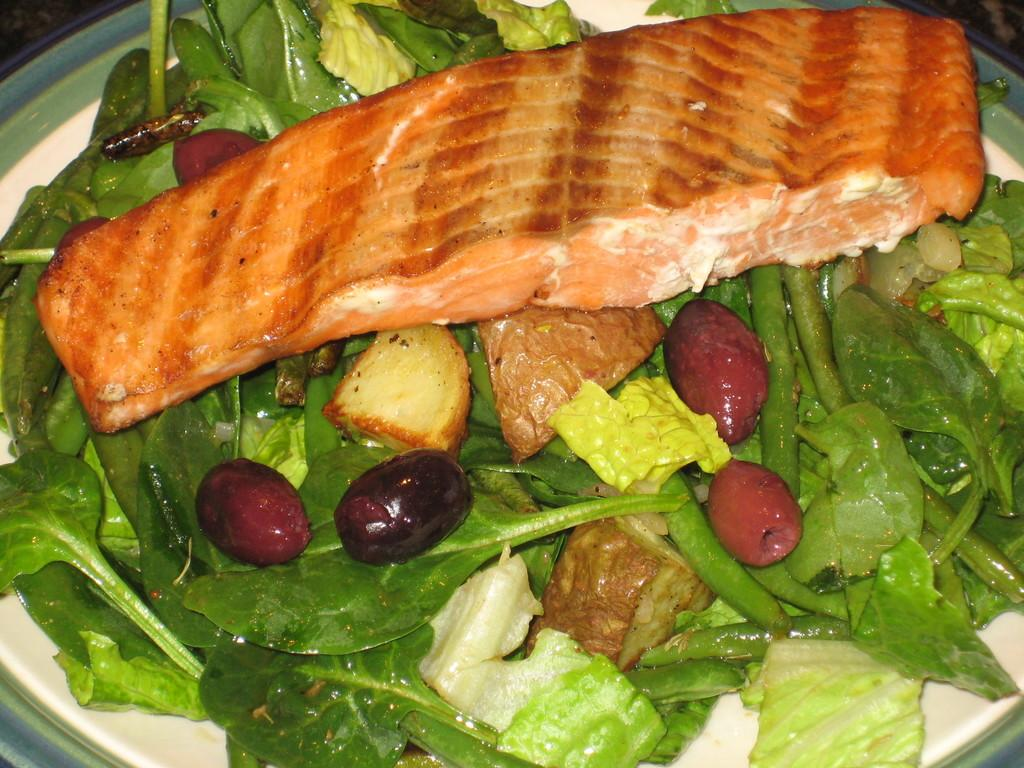What type of fish is on the plate in the image? There is fry fish on the plate. What other food items are on the plate? There are potato pieces and vegetables on the plate. Are there any other food items on the plate besides fish, potato pieces, and vegetables? Yes, there are other food items on the plate. Where is the plate located in the image? The plate is kept on a table. What effect does the thunder have on the geese in the image? There are no geese or thunder present in the image. 